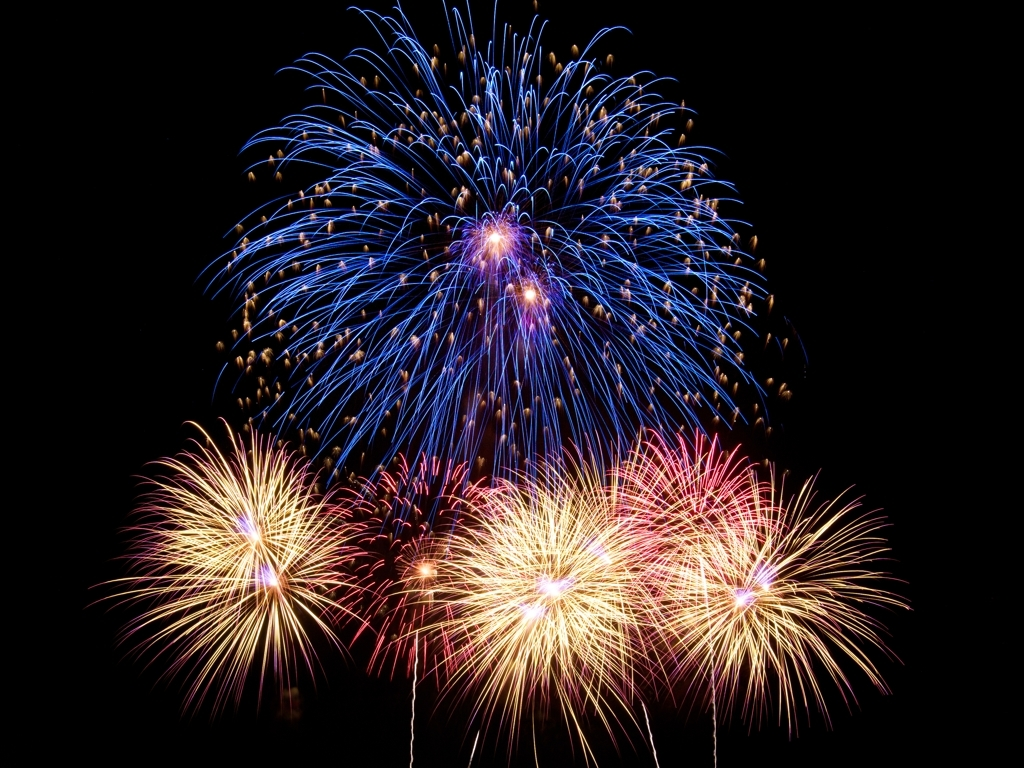Can you describe the different types of fireworks present in this image? Certainly! The image captures a variety of fireworks including peony-style bursts with trails that are indicative of a common shell type used in such displays. The bright, spherical centers suggest a chrysanthemum or peony arrangement, while the streaks portray comet or crossette effects. How are these effects achieved? These effects are achieved by the different compositions and arrangements of the pyrotechnic stars within the shell. When ignited, these stars burn to produce various colors and patterns. For example, comet shells have tails that follow the stars, and crossettes split into smaller stars, creating a crisscross effect. 